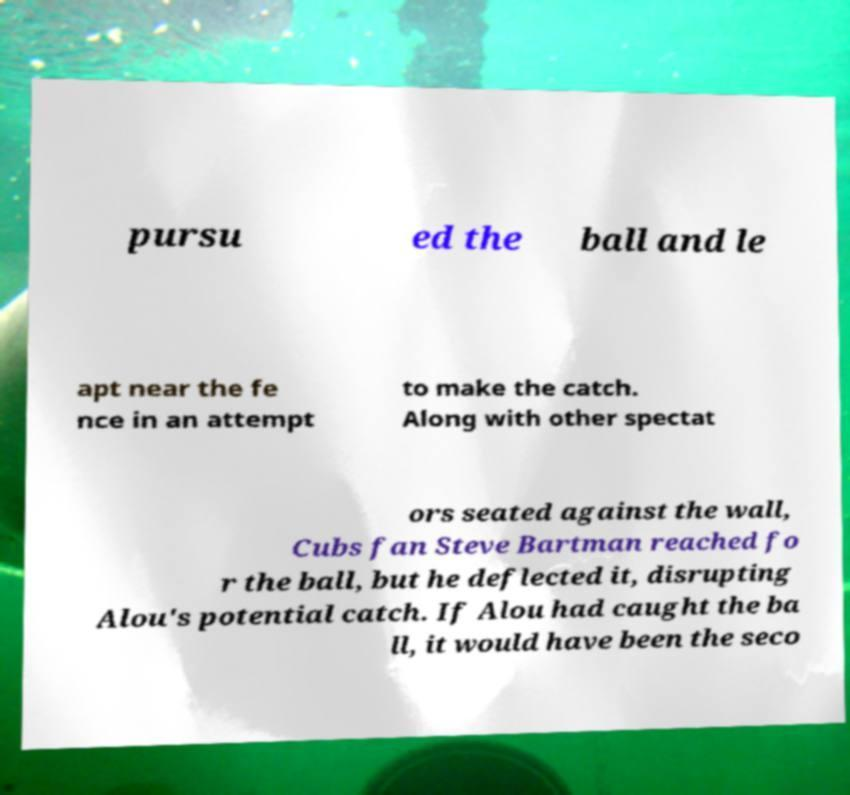There's text embedded in this image that I need extracted. Can you transcribe it verbatim? pursu ed the ball and le apt near the fe nce in an attempt to make the catch. Along with other spectat ors seated against the wall, Cubs fan Steve Bartman reached fo r the ball, but he deflected it, disrupting Alou's potential catch. If Alou had caught the ba ll, it would have been the seco 